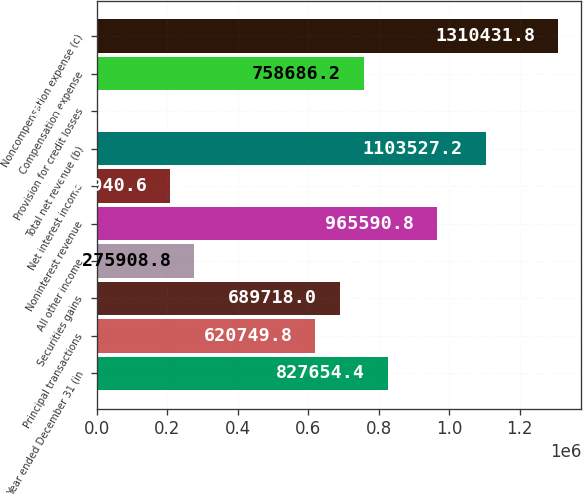Convert chart to OTSL. <chart><loc_0><loc_0><loc_500><loc_500><bar_chart><fcel>Year ended December 31 (in<fcel>Principal transactions<fcel>Securities gains<fcel>All other income<fcel>Noninterest revenue<fcel>Net interest income<fcel>Total net revenue (b)<fcel>Provision for credit losses<fcel>Compensation expense<fcel>Noncompensation expense (c)<nl><fcel>827654<fcel>620750<fcel>689718<fcel>275909<fcel>965591<fcel>206941<fcel>1.10353e+06<fcel>36<fcel>758686<fcel>1.31043e+06<nl></chart> 